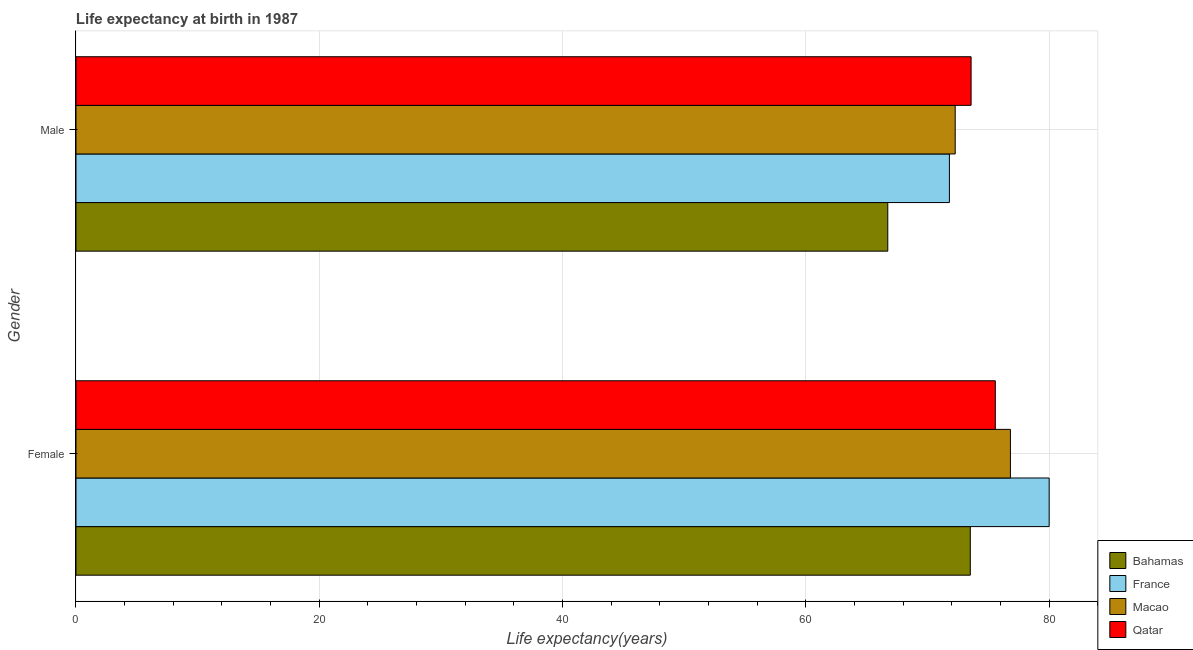How many groups of bars are there?
Your answer should be very brief. 2. How many bars are there on the 2nd tick from the top?
Give a very brief answer. 4. How many bars are there on the 2nd tick from the bottom?
Make the answer very short. 4. What is the label of the 1st group of bars from the top?
Ensure brevity in your answer.  Male. What is the life expectancy(male) in Qatar?
Your answer should be compact. 73.58. Across all countries, what is the maximum life expectancy(female)?
Offer a very short reply. 80. Across all countries, what is the minimum life expectancy(male)?
Provide a succinct answer. 66.73. In which country was the life expectancy(female) maximum?
Offer a very short reply. France. In which country was the life expectancy(female) minimum?
Keep it short and to the point. Bahamas. What is the total life expectancy(female) in the graph?
Give a very brief answer. 305.91. What is the difference between the life expectancy(male) in France and that in Macao?
Your answer should be very brief. -0.48. What is the difference between the life expectancy(female) in Macao and the life expectancy(male) in Qatar?
Your answer should be very brief. 3.23. What is the average life expectancy(female) per country?
Provide a succinct answer. 76.48. What is the difference between the life expectancy(male) and life expectancy(female) in Bahamas?
Ensure brevity in your answer.  -6.78. What is the ratio of the life expectancy(male) in France to that in Qatar?
Ensure brevity in your answer.  0.98. In how many countries, is the life expectancy(female) greater than the average life expectancy(female) taken over all countries?
Keep it short and to the point. 2. What does the 4th bar from the top in Male represents?
Make the answer very short. Bahamas. What does the 3rd bar from the bottom in Female represents?
Keep it short and to the point. Macao. How many bars are there?
Offer a terse response. 8. Are all the bars in the graph horizontal?
Ensure brevity in your answer.  Yes. How many countries are there in the graph?
Make the answer very short. 4. Are the values on the major ticks of X-axis written in scientific E-notation?
Your answer should be very brief. No. Does the graph contain grids?
Provide a short and direct response. Yes. Where does the legend appear in the graph?
Offer a very short reply. Bottom right. How many legend labels are there?
Provide a short and direct response. 4. How are the legend labels stacked?
Provide a succinct answer. Vertical. What is the title of the graph?
Offer a terse response. Life expectancy at birth in 1987. What is the label or title of the X-axis?
Keep it short and to the point. Life expectancy(years). What is the Life expectancy(years) in Bahamas in Female?
Your answer should be very brief. 73.52. What is the Life expectancy(years) of Macao in Female?
Make the answer very short. 76.82. What is the Life expectancy(years) in Qatar in Female?
Your response must be concise. 75.57. What is the Life expectancy(years) in Bahamas in Male?
Make the answer very short. 66.73. What is the Life expectancy(years) in France in Male?
Keep it short and to the point. 71.8. What is the Life expectancy(years) in Macao in Male?
Your response must be concise. 72.28. What is the Life expectancy(years) in Qatar in Male?
Provide a short and direct response. 73.58. Across all Gender, what is the maximum Life expectancy(years) in Bahamas?
Offer a very short reply. 73.52. Across all Gender, what is the maximum Life expectancy(years) of Macao?
Provide a succinct answer. 76.82. Across all Gender, what is the maximum Life expectancy(years) of Qatar?
Your answer should be compact. 75.57. Across all Gender, what is the minimum Life expectancy(years) in Bahamas?
Give a very brief answer. 66.73. Across all Gender, what is the minimum Life expectancy(years) of France?
Make the answer very short. 71.8. Across all Gender, what is the minimum Life expectancy(years) in Macao?
Offer a terse response. 72.28. Across all Gender, what is the minimum Life expectancy(years) of Qatar?
Provide a short and direct response. 73.58. What is the total Life expectancy(years) of Bahamas in the graph?
Keep it short and to the point. 140.25. What is the total Life expectancy(years) in France in the graph?
Keep it short and to the point. 151.8. What is the total Life expectancy(years) in Macao in the graph?
Offer a terse response. 149.09. What is the total Life expectancy(years) in Qatar in the graph?
Offer a very short reply. 149.16. What is the difference between the Life expectancy(years) of Bahamas in Female and that in Male?
Offer a very short reply. 6.78. What is the difference between the Life expectancy(years) in France in Female and that in Male?
Provide a succinct answer. 8.2. What is the difference between the Life expectancy(years) in Macao in Female and that in Male?
Ensure brevity in your answer.  4.54. What is the difference between the Life expectancy(years) in Qatar in Female and that in Male?
Make the answer very short. 1.99. What is the difference between the Life expectancy(years) of Bahamas in Female and the Life expectancy(years) of France in Male?
Offer a very short reply. 1.72. What is the difference between the Life expectancy(years) in Bahamas in Female and the Life expectancy(years) in Macao in Male?
Offer a terse response. 1.24. What is the difference between the Life expectancy(years) in Bahamas in Female and the Life expectancy(years) in Qatar in Male?
Keep it short and to the point. -0.07. What is the difference between the Life expectancy(years) of France in Female and the Life expectancy(years) of Macao in Male?
Provide a short and direct response. 7.72. What is the difference between the Life expectancy(years) of France in Female and the Life expectancy(years) of Qatar in Male?
Your answer should be compact. 6.42. What is the difference between the Life expectancy(years) of Macao in Female and the Life expectancy(years) of Qatar in Male?
Your answer should be compact. 3.23. What is the average Life expectancy(years) in Bahamas per Gender?
Your answer should be compact. 70.13. What is the average Life expectancy(years) in France per Gender?
Ensure brevity in your answer.  75.9. What is the average Life expectancy(years) in Macao per Gender?
Your response must be concise. 74.55. What is the average Life expectancy(years) in Qatar per Gender?
Give a very brief answer. 74.58. What is the difference between the Life expectancy(years) in Bahamas and Life expectancy(years) in France in Female?
Your answer should be very brief. -6.48. What is the difference between the Life expectancy(years) in Bahamas and Life expectancy(years) in Macao in Female?
Give a very brief answer. -3.3. What is the difference between the Life expectancy(years) in Bahamas and Life expectancy(years) in Qatar in Female?
Ensure brevity in your answer.  -2.06. What is the difference between the Life expectancy(years) in France and Life expectancy(years) in Macao in Female?
Offer a very short reply. 3.18. What is the difference between the Life expectancy(years) in France and Life expectancy(years) in Qatar in Female?
Make the answer very short. 4.43. What is the difference between the Life expectancy(years) in Macao and Life expectancy(years) in Qatar in Female?
Your response must be concise. 1.24. What is the difference between the Life expectancy(years) of Bahamas and Life expectancy(years) of France in Male?
Keep it short and to the point. -5.07. What is the difference between the Life expectancy(years) of Bahamas and Life expectancy(years) of Macao in Male?
Give a very brief answer. -5.54. What is the difference between the Life expectancy(years) of Bahamas and Life expectancy(years) of Qatar in Male?
Your response must be concise. -6.85. What is the difference between the Life expectancy(years) in France and Life expectancy(years) in Macao in Male?
Provide a succinct answer. -0.48. What is the difference between the Life expectancy(years) of France and Life expectancy(years) of Qatar in Male?
Offer a terse response. -1.78. What is the difference between the Life expectancy(years) in Macao and Life expectancy(years) in Qatar in Male?
Your answer should be compact. -1.31. What is the ratio of the Life expectancy(years) in Bahamas in Female to that in Male?
Your response must be concise. 1.1. What is the ratio of the Life expectancy(years) of France in Female to that in Male?
Offer a very short reply. 1.11. What is the ratio of the Life expectancy(years) of Macao in Female to that in Male?
Provide a short and direct response. 1.06. What is the difference between the highest and the second highest Life expectancy(years) of Bahamas?
Provide a short and direct response. 6.78. What is the difference between the highest and the second highest Life expectancy(years) in Macao?
Offer a very short reply. 4.54. What is the difference between the highest and the second highest Life expectancy(years) in Qatar?
Your answer should be compact. 1.99. What is the difference between the highest and the lowest Life expectancy(years) in Bahamas?
Keep it short and to the point. 6.78. What is the difference between the highest and the lowest Life expectancy(years) in Macao?
Keep it short and to the point. 4.54. What is the difference between the highest and the lowest Life expectancy(years) of Qatar?
Your answer should be very brief. 1.99. 